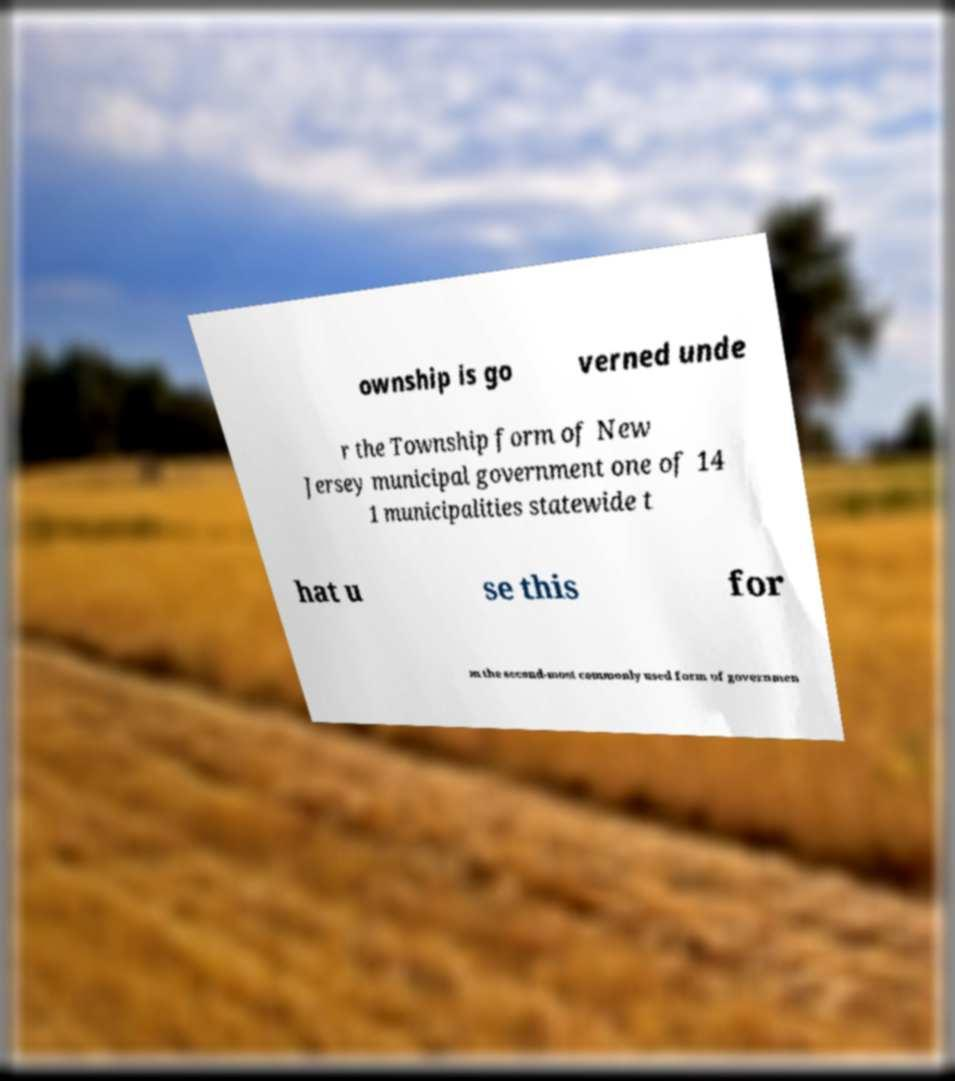For documentation purposes, I need the text within this image transcribed. Could you provide that? ownship is go verned unde r the Township form of New Jersey municipal government one of 14 1 municipalities statewide t hat u se this for m the second-most commonly used form of governmen 